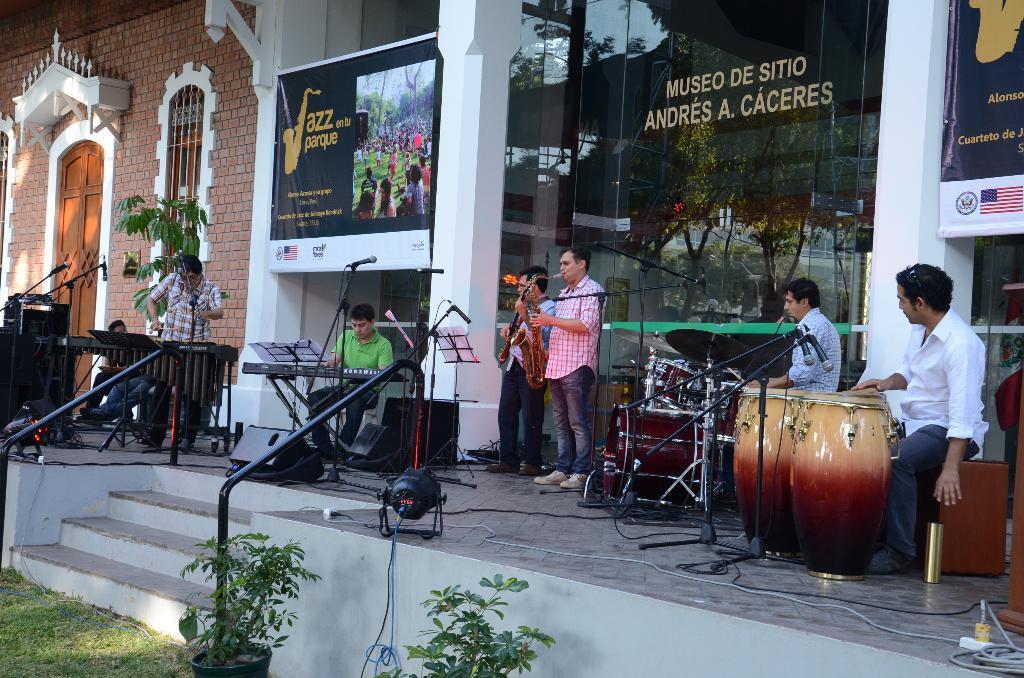In one or two sentences, can you explain what this image depicts? On the stage there are six people standing. To the right corner there is a man playing drums. Beside him there is a man he is also playing drums. Two persons standing side by side are playing saxophones. And a man with green t-shirt is playing a piano. In the background there is a building with glass and some posters. And to the left side corner there is a door and a window. 